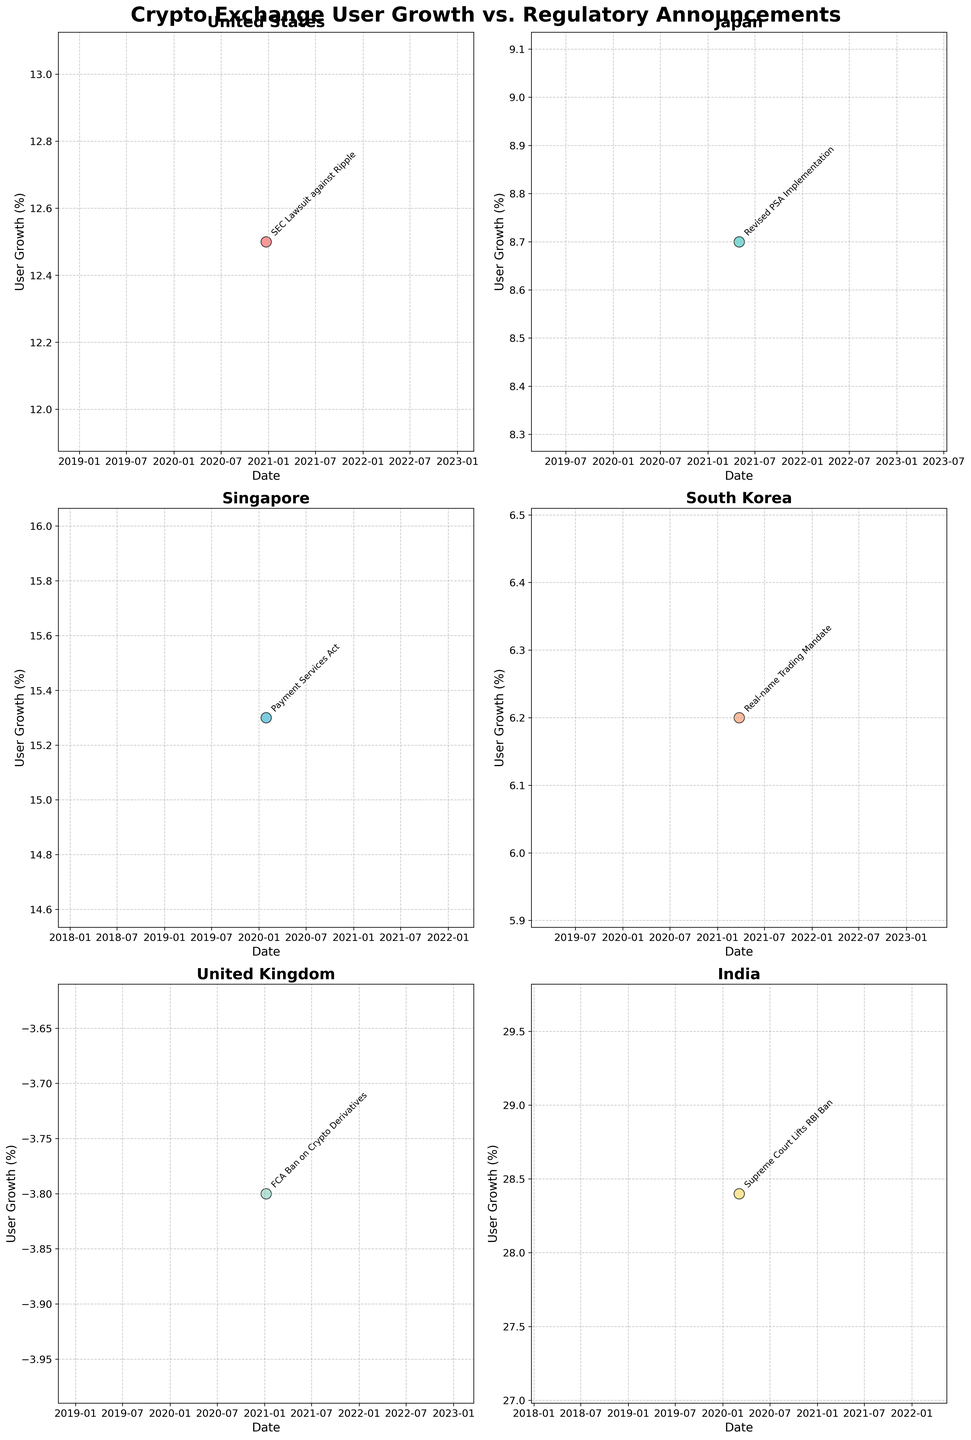How many scatter plots are present in the figure? The figure contains subplots for six different countries, each represented by a separate scatter plot. Count the number of subplots to answer.
Answer: 6 Which country recorded the highest user growth, and what event was that growth associated with? In the figure, El Salvador recorded the highest user growth at 41.2%. This growth is associated with the "Bitcoin Legal Tender Announcement" on 2021-06-09. Check the specific user growth percentages and annotations in the plots to find this.
Answer: El Salvador, Bitcoin Legal Tender Announcement What is the user growth percentage related to the "SEC Lawsuit against Ripple" in the United States? Look at the subplot for the United States and find the data point labeled "SEC Lawsuit against Ripple". The user growth percentage associated with this event is marked on the y-axis.
Answer: 12.5% Which country experienced a decline in user growth, and what was the regulatory announcement related to it? The subplot for the United Kingdom shows a data point below the x-axis with negative growth. The related regulatory announcement is the "FCA Ban on Crypto Derivatives".
Answer: United Kingdom, FCA Ban on Crypto Derivatives Compare the user growth in Singapore and South Korea. Which country saw a higher user growth percentage and by how much? Check the subplots for both Singapore and South Korea. Singapore shows a user growth of 15.3%, while South Korea shows 6.2%. The difference between the two percentages is 15.3 - 6.2 = 9.1%.
Answer: Singapore, 9.1% What is the trend in user growth related to regulatory announcements in the United States around 2020-12-22? Look at the scatter plot for the United States. The data point for 2020-12-22 indicates a user growth of 12.5%, which shows an increase. Check surrounding dates if needed to infer the trend.
Answer: Increasing Which regulatory announcement in Japan corresponds to a user growth of 8.7%, and when did it occur? Check the subplot for Japan and locate the data point at 8.7% user growth. The corresponding annotation is the "Revised PSA Implementation" which occurred on 2021-05-01.
Answer: Revised PSA Implementation, 2021-05-01 What is the average user growth across the countries shown in the figure? Add the user growth percentages for all the countries shown in the subplot: 12.5 + 8.7 + 15.3 + 6.2 + (-3.8) + 28.4 = 67.3. Divide by the number of countries (6). The average is 67.3 / 6.
Answer: 11.22% Which regulatory action led to the negative highest user growth across all subplots? Identify the subplot with the lowest data point. The China subplot shows the lowest value at -18.6%, associated with the "Mining Ban Announcement" on 2021-05-21.
Answer: Mining Ban Announcement in China 